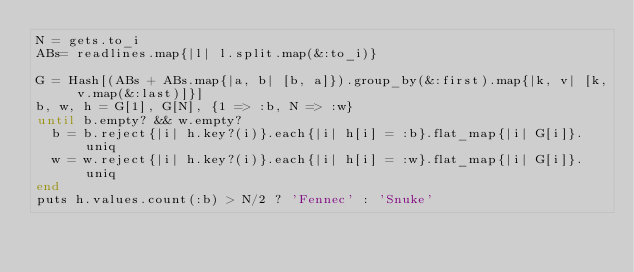Convert code to text. <code><loc_0><loc_0><loc_500><loc_500><_Ruby_>N = gets.to_i
ABs= readlines.map{|l| l.split.map(&:to_i)}

G = Hash[(ABs + ABs.map{|a, b| [b, a]}).group_by(&:first).map{|k, v| [k, v.map(&:last)]}]
b, w, h = G[1], G[N], {1 => :b, N => :w}
until b.empty? && w.empty?
  b = b.reject{|i| h.key?(i)}.each{|i| h[i] = :b}.flat_map{|i| G[i]}.uniq
  w = w.reject{|i| h.key?(i)}.each{|i| h[i] = :w}.flat_map{|i| G[i]}.uniq
end
puts h.values.count(:b) > N/2 ? 'Fennec' : 'Snuke'</code> 